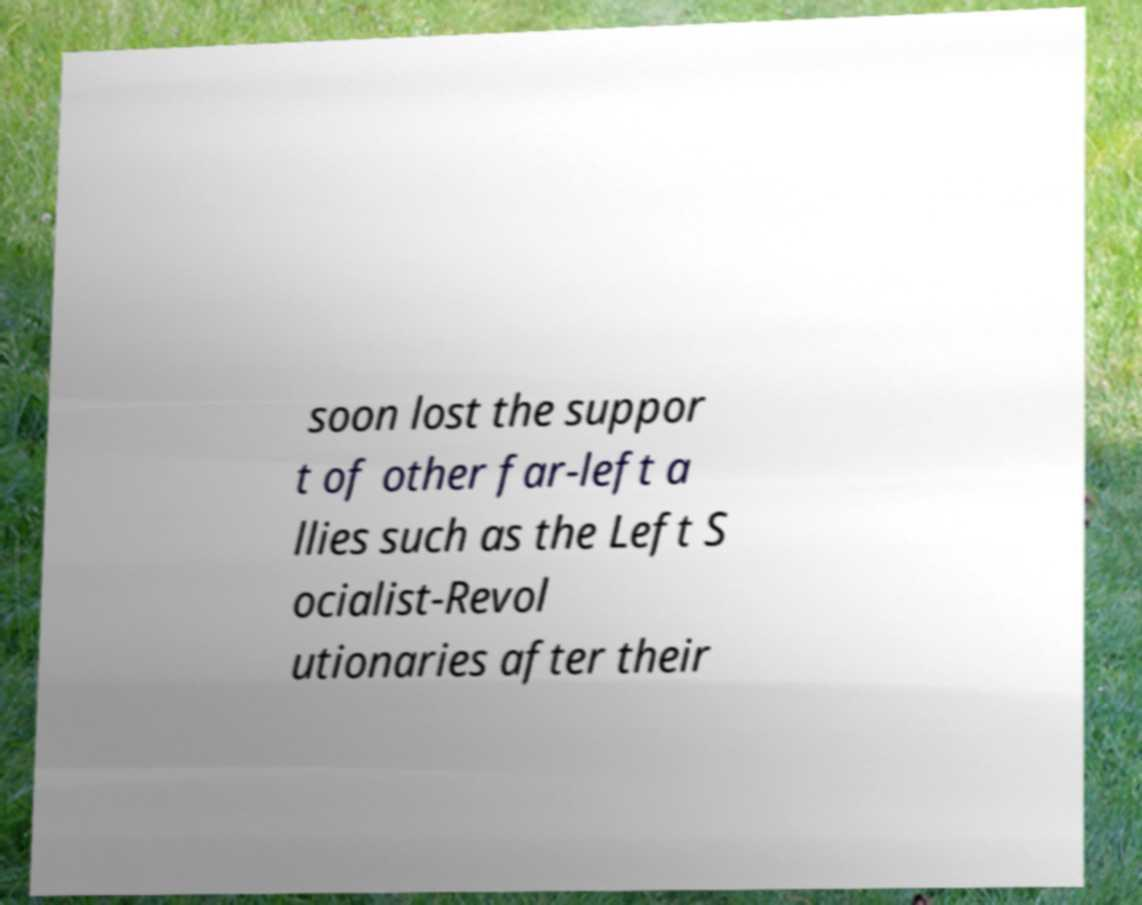Please read and relay the text visible in this image. What does it say? soon lost the suppor t of other far-left a llies such as the Left S ocialist-Revol utionaries after their 